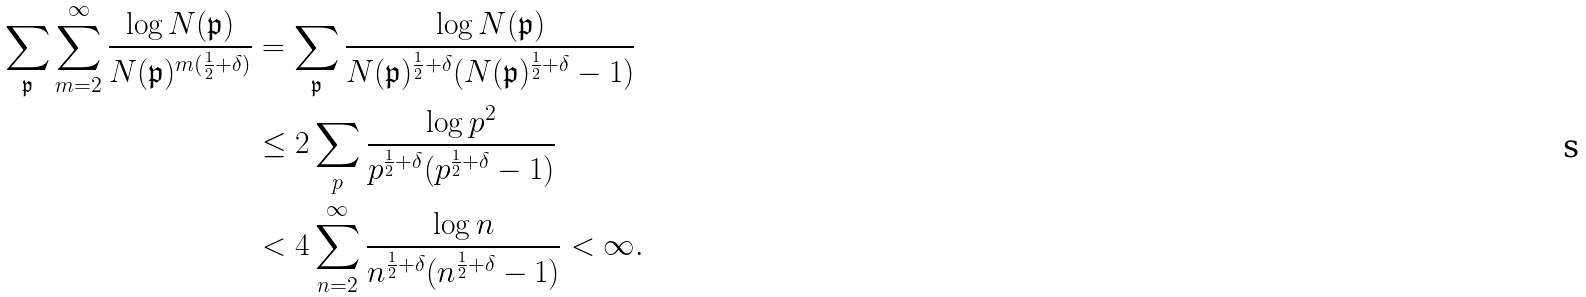Convert formula to latex. <formula><loc_0><loc_0><loc_500><loc_500>\sum _ { \mathfrak { p } } \sum _ { m = 2 } ^ { \infty } \frac { \log N ( \mathfrak { p } ) } { N ( \mathfrak { p } ) ^ { m ( \frac { 1 } { 2 } + \delta ) } } & = \sum _ { \mathfrak { p } } \frac { \log N ( \mathfrak { p } ) } { N ( \mathfrak { p } ) ^ { \frac { 1 } { 2 } + \delta } ( N ( \mathfrak { p } ) ^ { \frac { 1 } { 2 } + \delta } - 1 ) } \\ & \leq 2 \sum _ { p } \frac { \log p ^ { 2 } } { p ^ { \frac { 1 } { 2 } + \delta } ( p ^ { \frac { 1 } { 2 } + \delta } - 1 ) } \\ & < 4 \sum _ { n = 2 } ^ { \infty } \frac { \log n } { n ^ { \frac { 1 } { 2 } + \delta } ( n ^ { \frac { 1 } { 2 } + \delta } - 1 ) } < \infty .</formula> 